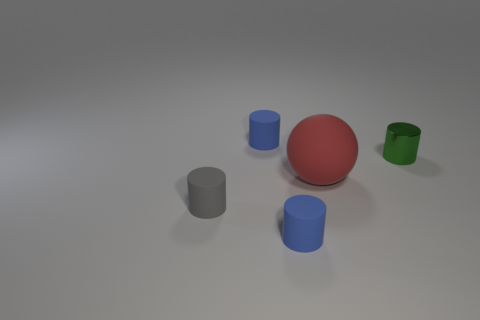What number of things are both behind the tiny shiny thing and in front of the large red object?
Ensure brevity in your answer.  0. There is a green thing that is the same shape as the small gray object; what material is it?
Keep it short and to the point. Metal. Is there anything else that has the same material as the green cylinder?
Offer a terse response. No. Are there the same number of small green cylinders in front of the big red ball and big things on the left side of the gray matte cylinder?
Make the answer very short. Yes. Does the large sphere have the same material as the gray cylinder?
Your answer should be very brief. Yes. What number of blue objects are rubber cylinders or metallic objects?
Give a very brief answer. 2. How many tiny rubber objects have the same shape as the metal thing?
Provide a short and direct response. 3. What is the green thing made of?
Make the answer very short. Metal. Are there an equal number of small blue rubber objects behind the gray thing and tiny green metal cylinders?
Give a very brief answer. Yes. The gray rubber object that is the same size as the green object is what shape?
Your response must be concise. Cylinder. 